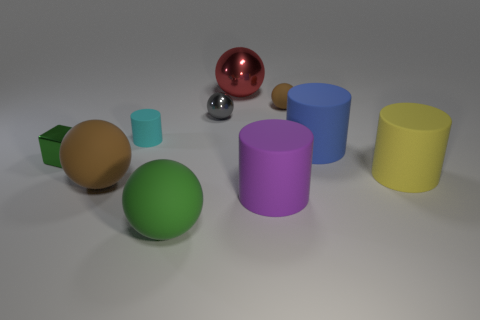There is a yellow cylinder behind the brown rubber ball that is in front of the brown rubber ball behind the tiny cyan thing; how big is it?
Your answer should be compact. Large. Does the red thing have the same material as the brown ball that is right of the cyan cylinder?
Give a very brief answer. No. Do the gray metallic thing and the green matte object have the same shape?
Offer a very short reply. Yes. How many other objects are there of the same material as the big blue cylinder?
Offer a terse response. 6. What number of gray metallic things are the same shape as the small cyan rubber thing?
Make the answer very short. 0. What is the color of the shiny object that is both behind the blue rubber object and in front of the large red object?
Keep it short and to the point. Gray. What number of large brown matte cubes are there?
Your answer should be compact. 0. Does the red shiny sphere have the same size as the blue rubber object?
Your answer should be very brief. Yes. Are there any tiny cylinders that have the same color as the tiny metal block?
Your response must be concise. No. There is a shiny object that is in front of the gray ball; is it the same shape as the large metal thing?
Your response must be concise. No. 